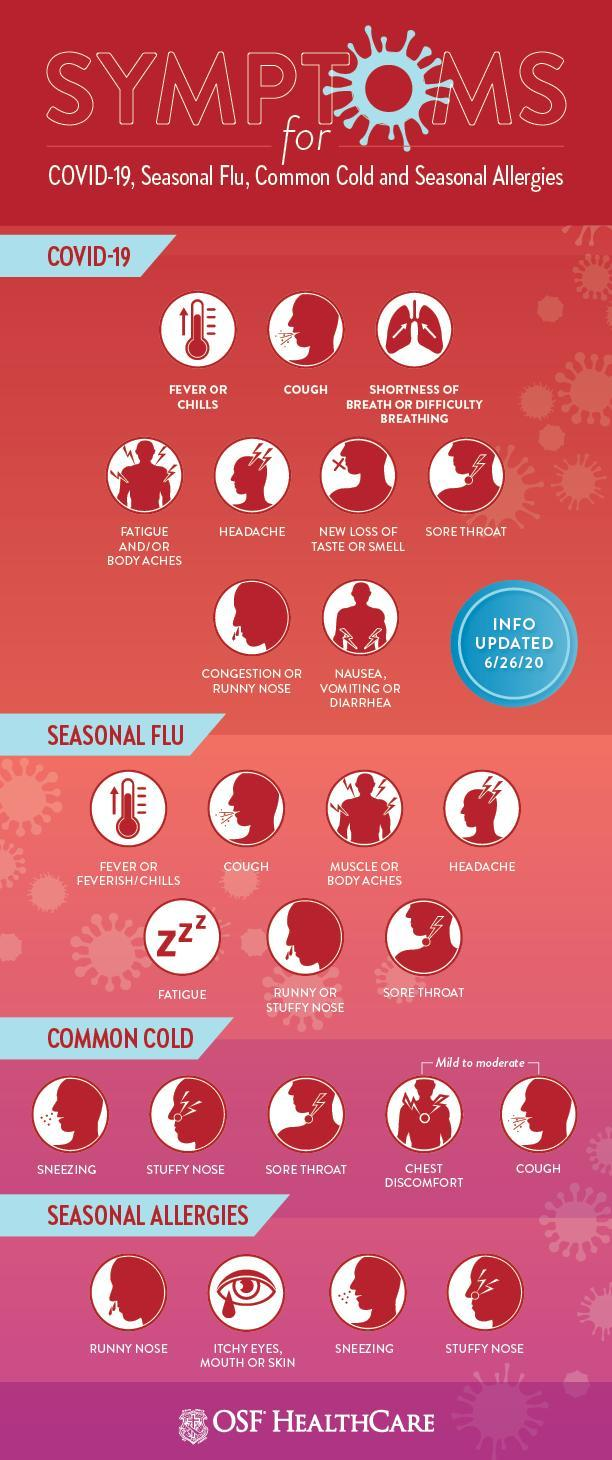Which symptoms are common for both COVID-19 & common cold?
Answer the question with a short phrase. COUGH, SORE THROAT Which symptoms are common for both cold & seasonal allergies? SNEEZING, STUFFY NOSE 